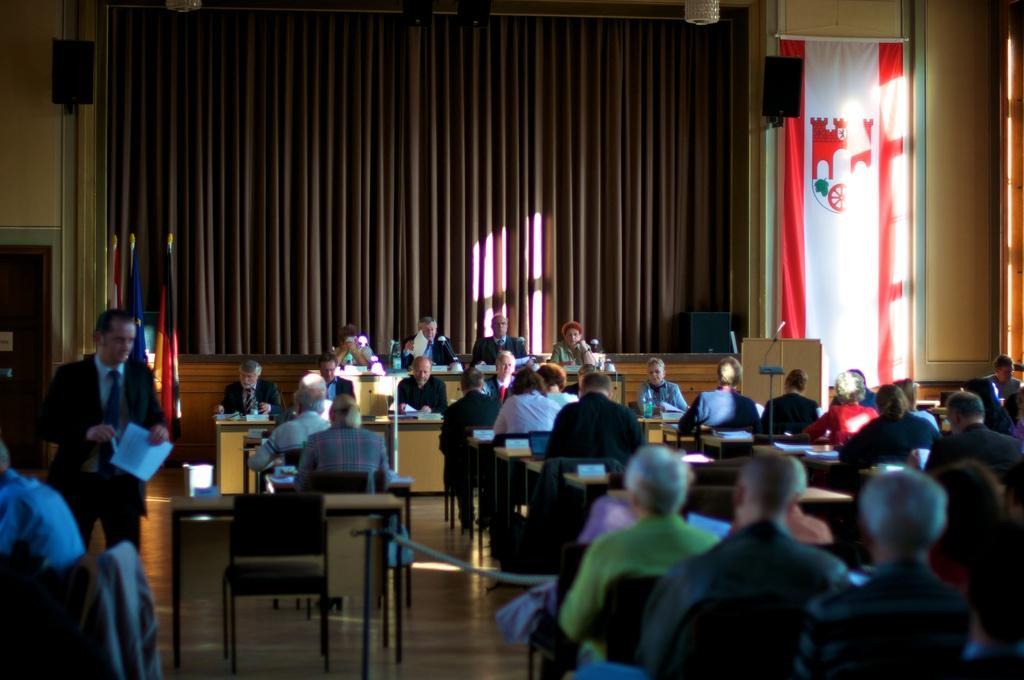Please provide a concise description of this image. In this picture there are a group of people sitting and standing, holding papers. In the backdrop there is a curtain. 